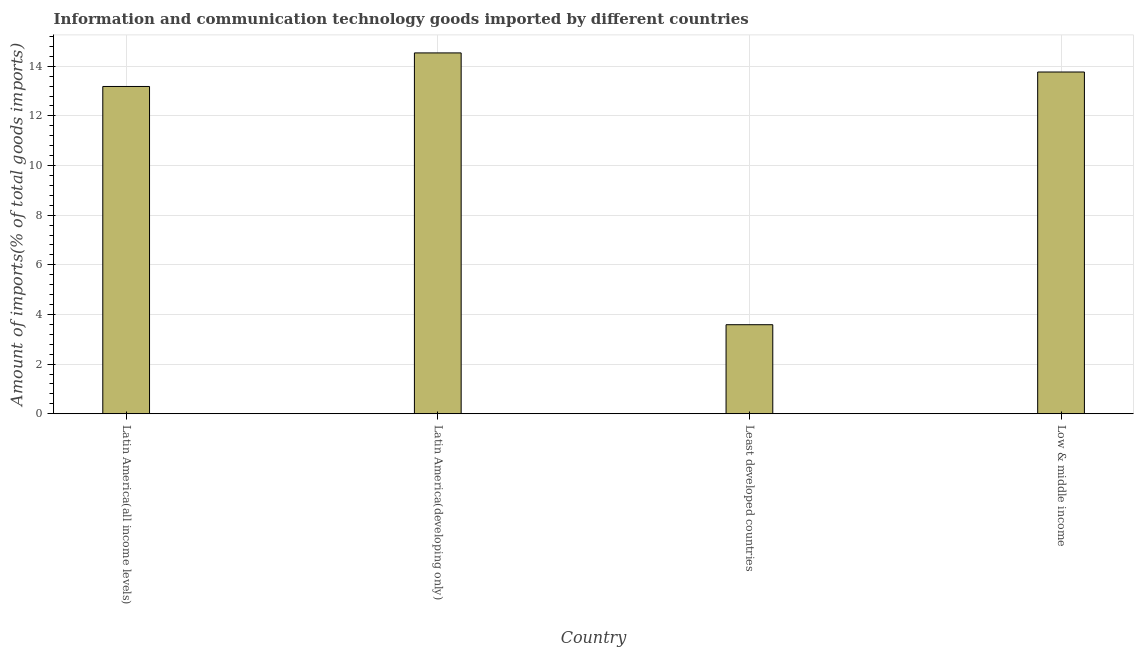Does the graph contain any zero values?
Your answer should be compact. No. Does the graph contain grids?
Offer a very short reply. Yes. What is the title of the graph?
Offer a very short reply. Information and communication technology goods imported by different countries. What is the label or title of the Y-axis?
Your answer should be compact. Amount of imports(% of total goods imports). What is the amount of ict goods imports in Latin America(developing only)?
Make the answer very short. 14.54. Across all countries, what is the maximum amount of ict goods imports?
Provide a succinct answer. 14.54. Across all countries, what is the minimum amount of ict goods imports?
Your answer should be very brief. 3.59. In which country was the amount of ict goods imports maximum?
Make the answer very short. Latin America(developing only). In which country was the amount of ict goods imports minimum?
Offer a very short reply. Least developed countries. What is the sum of the amount of ict goods imports?
Ensure brevity in your answer.  45.07. What is the difference between the amount of ict goods imports in Least developed countries and Low & middle income?
Keep it short and to the point. -10.18. What is the average amount of ict goods imports per country?
Provide a succinct answer. 11.27. What is the median amount of ict goods imports?
Your answer should be very brief. 13.48. In how many countries, is the amount of ict goods imports greater than 12 %?
Make the answer very short. 3. What is the ratio of the amount of ict goods imports in Latin America(all income levels) to that in Least developed countries?
Offer a very short reply. 3.68. What is the difference between the highest and the second highest amount of ict goods imports?
Offer a terse response. 0.77. Is the sum of the amount of ict goods imports in Latin America(all income levels) and Latin America(developing only) greater than the maximum amount of ict goods imports across all countries?
Keep it short and to the point. Yes. What is the difference between the highest and the lowest amount of ict goods imports?
Your answer should be compact. 10.95. Are all the bars in the graph horizontal?
Provide a short and direct response. No. What is the Amount of imports(% of total goods imports) of Latin America(all income levels)?
Your answer should be very brief. 13.18. What is the Amount of imports(% of total goods imports) in Latin America(developing only)?
Keep it short and to the point. 14.54. What is the Amount of imports(% of total goods imports) of Least developed countries?
Offer a terse response. 3.59. What is the Amount of imports(% of total goods imports) in Low & middle income?
Provide a succinct answer. 13.77. What is the difference between the Amount of imports(% of total goods imports) in Latin America(all income levels) and Latin America(developing only)?
Your answer should be very brief. -1.35. What is the difference between the Amount of imports(% of total goods imports) in Latin America(all income levels) and Least developed countries?
Offer a very short reply. 9.6. What is the difference between the Amount of imports(% of total goods imports) in Latin America(all income levels) and Low & middle income?
Keep it short and to the point. -0.58. What is the difference between the Amount of imports(% of total goods imports) in Latin America(developing only) and Least developed countries?
Keep it short and to the point. 10.95. What is the difference between the Amount of imports(% of total goods imports) in Latin America(developing only) and Low & middle income?
Your answer should be compact. 0.77. What is the difference between the Amount of imports(% of total goods imports) in Least developed countries and Low & middle income?
Give a very brief answer. -10.18. What is the ratio of the Amount of imports(% of total goods imports) in Latin America(all income levels) to that in Latin America(developing only)?
Your answer should be compact. 0.91. What is the ratio of the Amount of imports(% of total goods imports) in Latin America(all income levels) to that in Least developed countries?
Provide a short and direct response. 3.68. What is the ratio of the Amount of imports(% of total goods imports) in Latin America(all income levels) to that in Low & middle income?
Offer a very short reply. 0.96. What is the ratio of the Amount of imports(% of total goods imports) in Latin America(developing only) to that in Least developed countries?
Provide a succinct answer. 4.05. What is the ratio of the Amount of imports(% of total goods imports) in Latin America(developing only) to that in Low & middle income?
Provide a succinct answer. 1.06. What is the ratio of the Amount of imports(% of total goods imports) in Least developed countries to that in Low & middle income?
Offer a terse response. 0.26. 